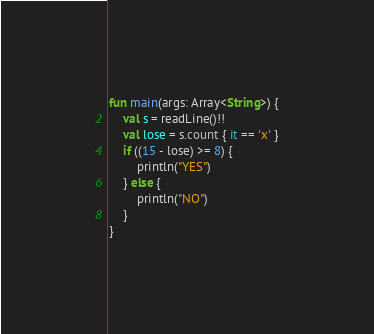Convert code to text. <code><loc_0><loc_0><loc_500><loc_500><_Kotlin_>fun main(args: Array<String>) {
    val s = readLine()!!
    val lose = s.count { it == 'x' }
    if ((15 - lose) >= 8) {
        println("YES")
    } else {
        println("NO")
    }
}
</code> 